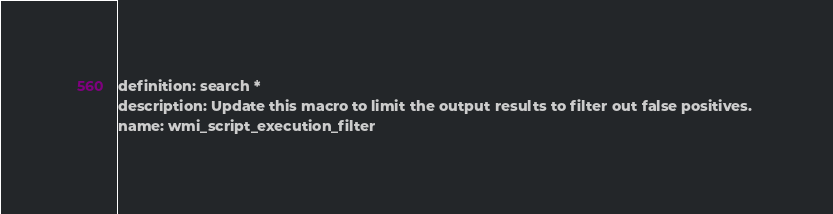<code> <loc_0><loc_0><loc_500><loc_500><_YAML_>definition: search *
description: Update this macro to limit the output results to filter out false positives. 
name: wmi_script_execution_filter</code> 